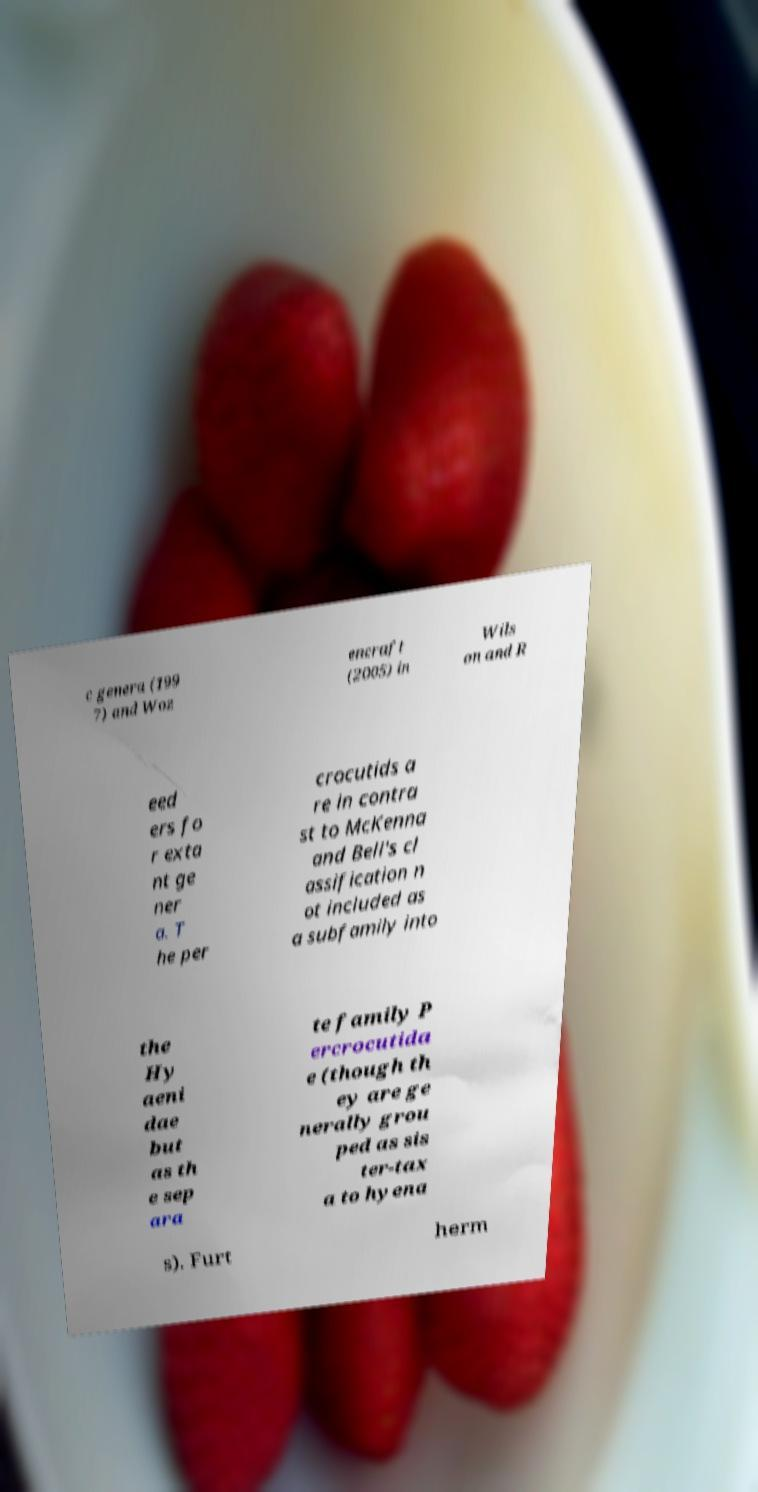Can you read and provide the text displayed in the image?This photo seems to have some interesting text. Can you extract and type it out for me? c genera (199 7) and Woz encraft (2005) in Wils on and R eed ers fo r exta nt ge ner a. T he per crocutids a re in contra st to McKenna and Bell's cl assification n ot included as a subfamily into the Hy aeni dae but as th e sep ara te family P ercrocutida e (though th ey are ge nerally grou ped as sis ter-tax a to hyena s). Furt herm 